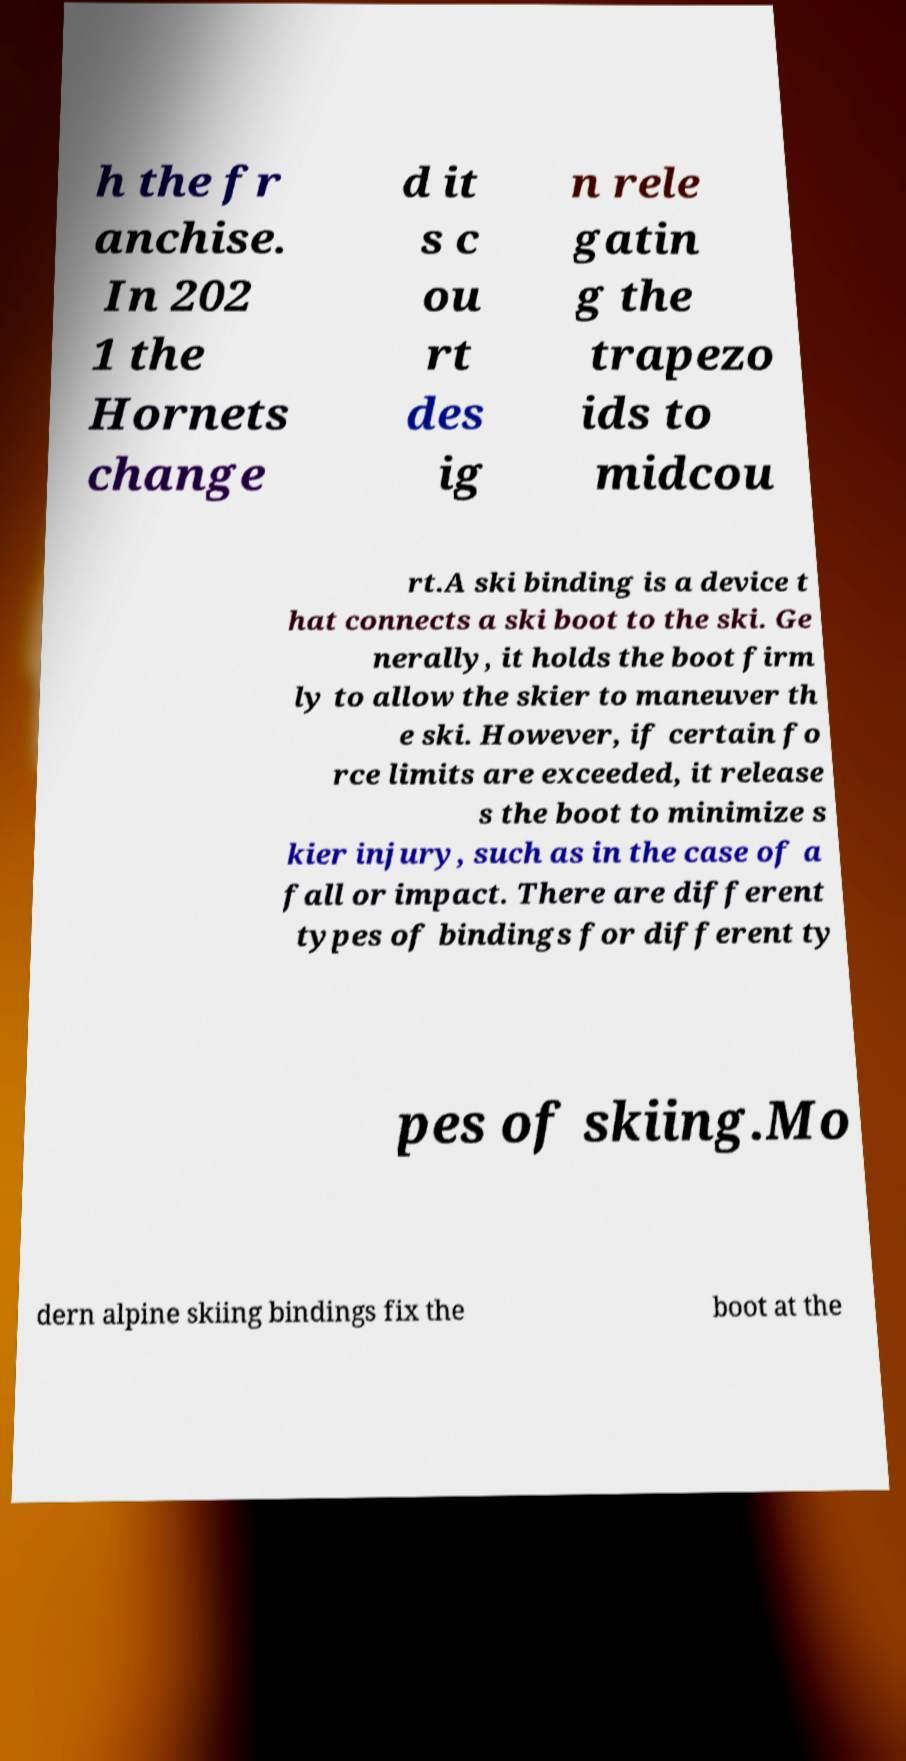I need the written content from this picture converted into text. Can you do that? h the fr anchise. In 202 1 the Hornets change d it s c ou rt des ig n rele gatin g the trapezo ids to midcou rt.A ski binding is a device t hat connects a ski boot to the ski. Ge nerally, it holds the boot firm ly to allow the skier to maneuver th e ski. However, if certain fo rce limits are exceeded, it release s the boot to minimize s kier injury, such as in the case of a fall or impact. There are different types of bindings for different ty pes of skiing.Mo dern alpine skiing bindings fix the boot at the 